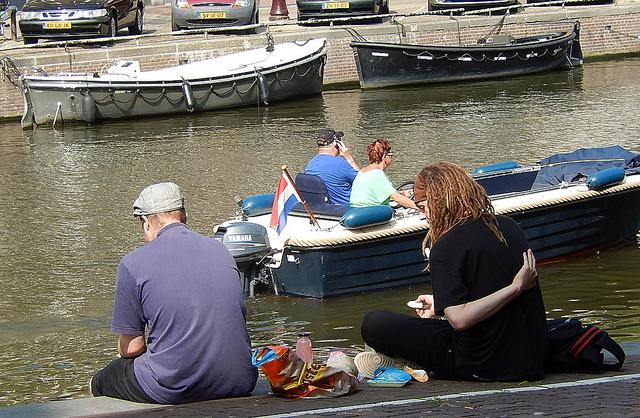A small vessel for travelling over water propelled by oars sails or an engine is? Please explain your reasoning. boat. Boats go on the water. 